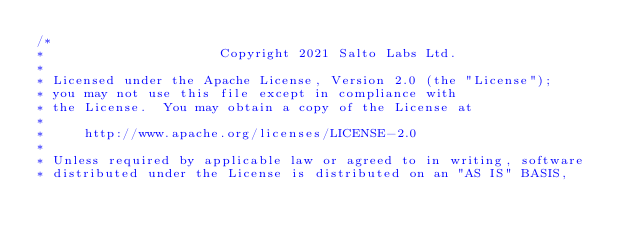Convert code to text. <code><loc_0><loc_0><loc_500><loc_500><_TypeScript_>/*
*                      Copyright 2021 Salto Labs Ltd.
*
* Licensed under the Apache License, Version 2.0 (the "License");
* you may not use this file except in compliance with
* the License.  You may obtain a copy of the License at
*
*     http://www.apache.org/licenses/LICENSE-2.0
*
* Unless required by applicable law or agreed to in writing, software
* distributed under the License is distributed on an "AS IS" BASIS,</code> 